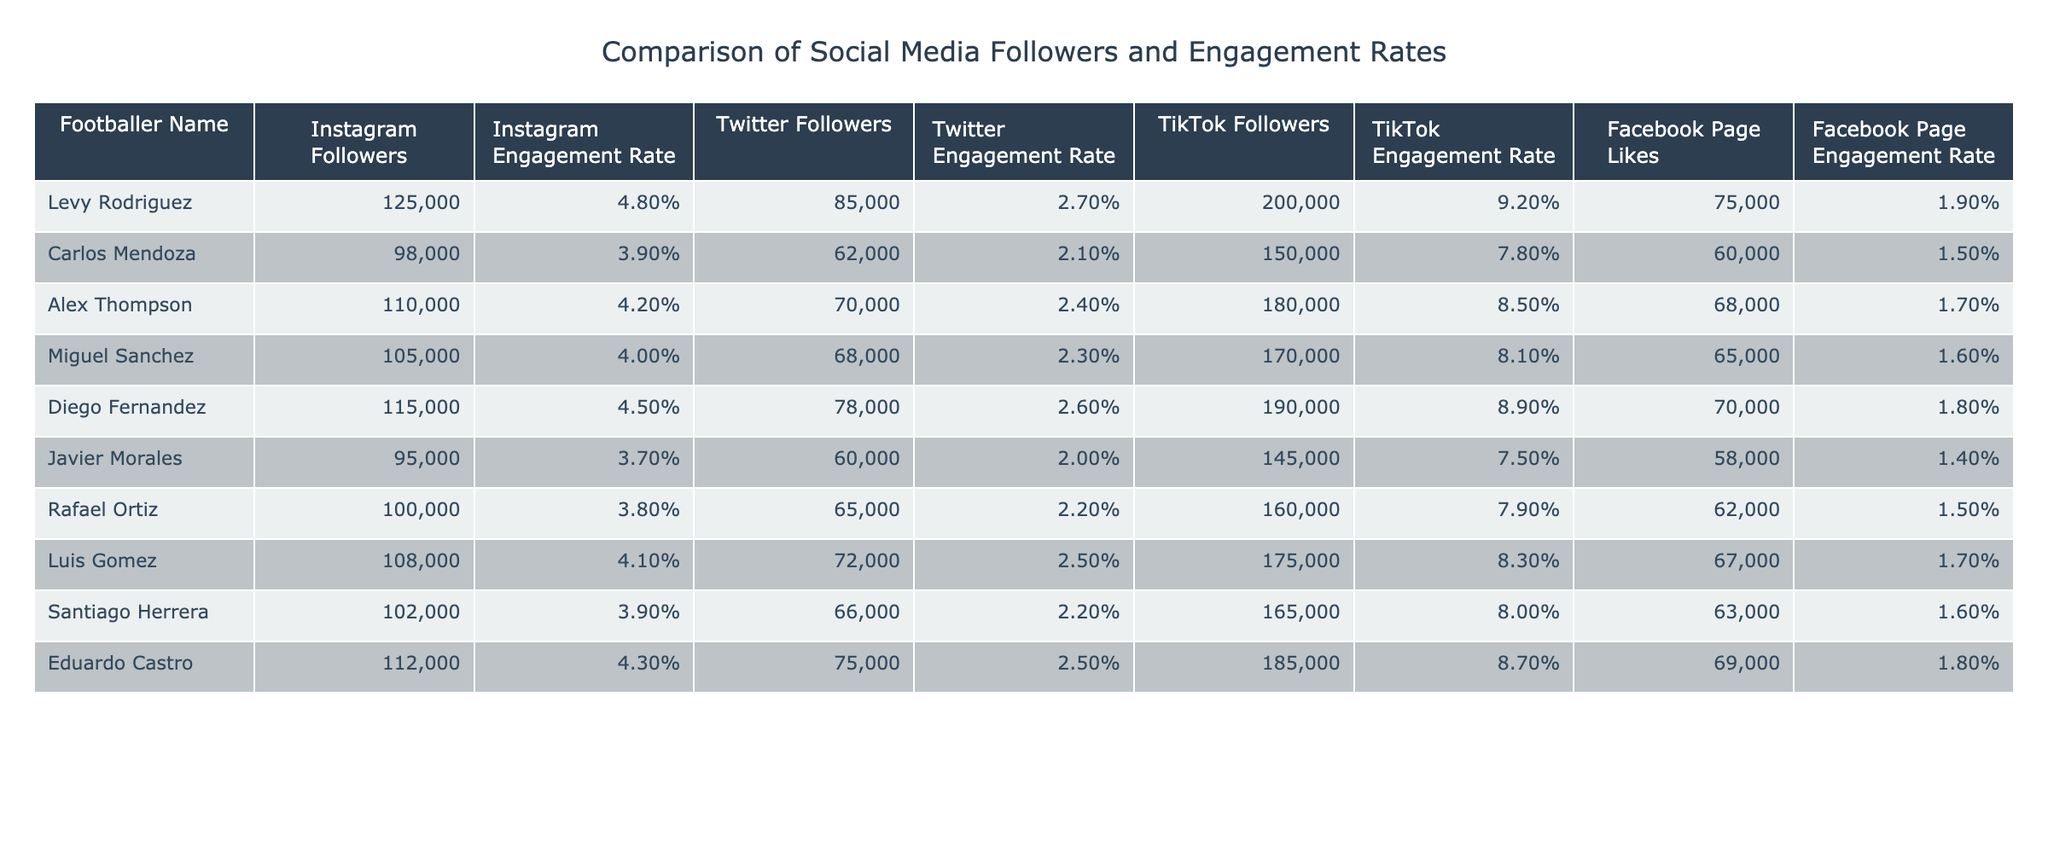What is the engagement rate of Levy Rodriguez on Instagram? The table shows Levy Rodriguez's Instagram Engagement Rate as 4.8%.
Answer: 4.8% Which footballer has the highest TikTok followers? By comparing the TikTok followers' column, Diego Fernandez has the highest with 190,000 followers.
Answer: Diego Fernandez What is the total number of Instagram followers across all footballers? Adding the Instagram followers for each footballer: 125,000 + 98,000 + 110,000 + 105,000 + 115,000 + 95,000 + 100,000 + 108,000 + 102,000 + 112,000 = 1,115,000.
Answer: 1,115,000 Is the engagement rate on TikTok for Carlos Mendoza higher than that for Javier Morales? Carlos Mendoza's TikTok Engagement Rate is 7.8%, and Javier Morales's is 7.5%, so yes, it is higher.
Answer: Yes What is the difference in Facebook Page Likes between Alex Thompson and Rafael Ortiz? Alex Thompson has 68,000 likes, and Rafael Ortiz has 62,000 likes; the difference is 68,000 - 62,000 = 6,000.
Answer: 6,000 Who has more Twitter followers, Diego Fernandez or Luis Gomez? Diego Fernandez has 78,000 Twitter followers while Luis Gomez has 72,000; therefore, Diego Fernandez has more.
Answer: Diego Fernandez What is the average engagement rate on Instagram for all footballers? To find the average, we sum the Instagram engagement rates: (4.8 + 3.9 + 4.2 + 4.0 + 4.5 + 3.7 + 3.8 + 4.1 + 3.9 + 4.3) / 10 = 4.08%.
Answer: 4.08% Are the total Facebook Page Likes for Eduardo Castro and Carlos Mendoza combined greater than that of Levy Rodriguez? Eduardo Castro has 69,000 and Carlos Mendoza has 60,000, which totals 129,000; Levy has 75,000 likes, so 129,000 > 75,000 is true.
Answer: Yes What is the least social media engagement rate among the footballers on Facebook? The Facebook Page Engagement Rate for Javier Morales is 1.4%, which is the lowest on the table.
Answer: 1.4% Which player has the closest engagement rate on Twitter compared to Eduardo Castro? Eduardo Castro has an engagement rate of 2.5% on Twitter; Miguel Sanchez also has 2.3%, which is the closest when compared to others.
Answer: Miguel Sanchez 